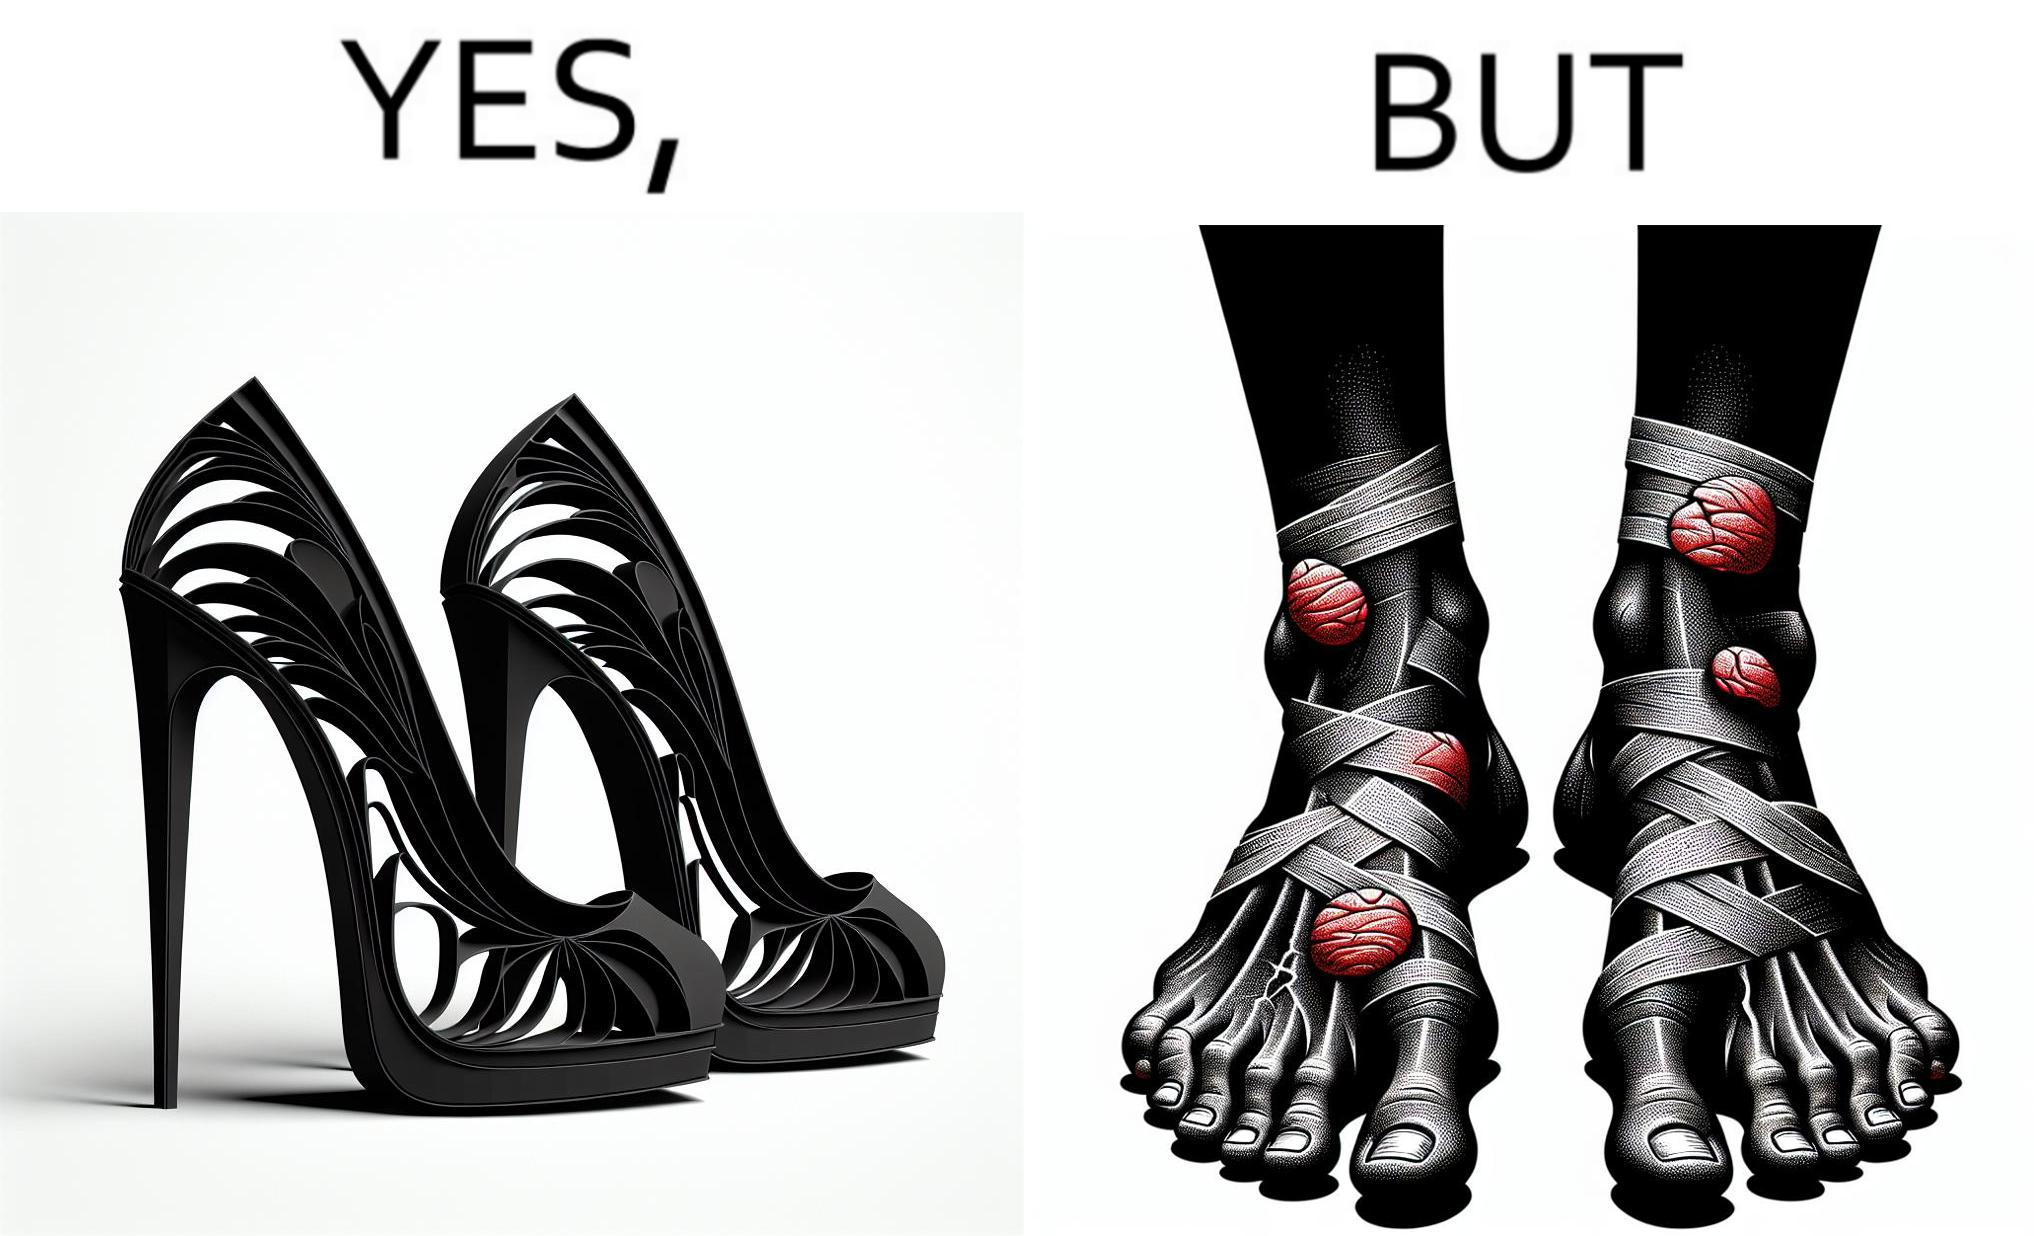What is shown in this image? The images are funny since they show how the prettiest footwears like high heels, end up causing a lot of physical discomfort to the user, all in the name fashion 